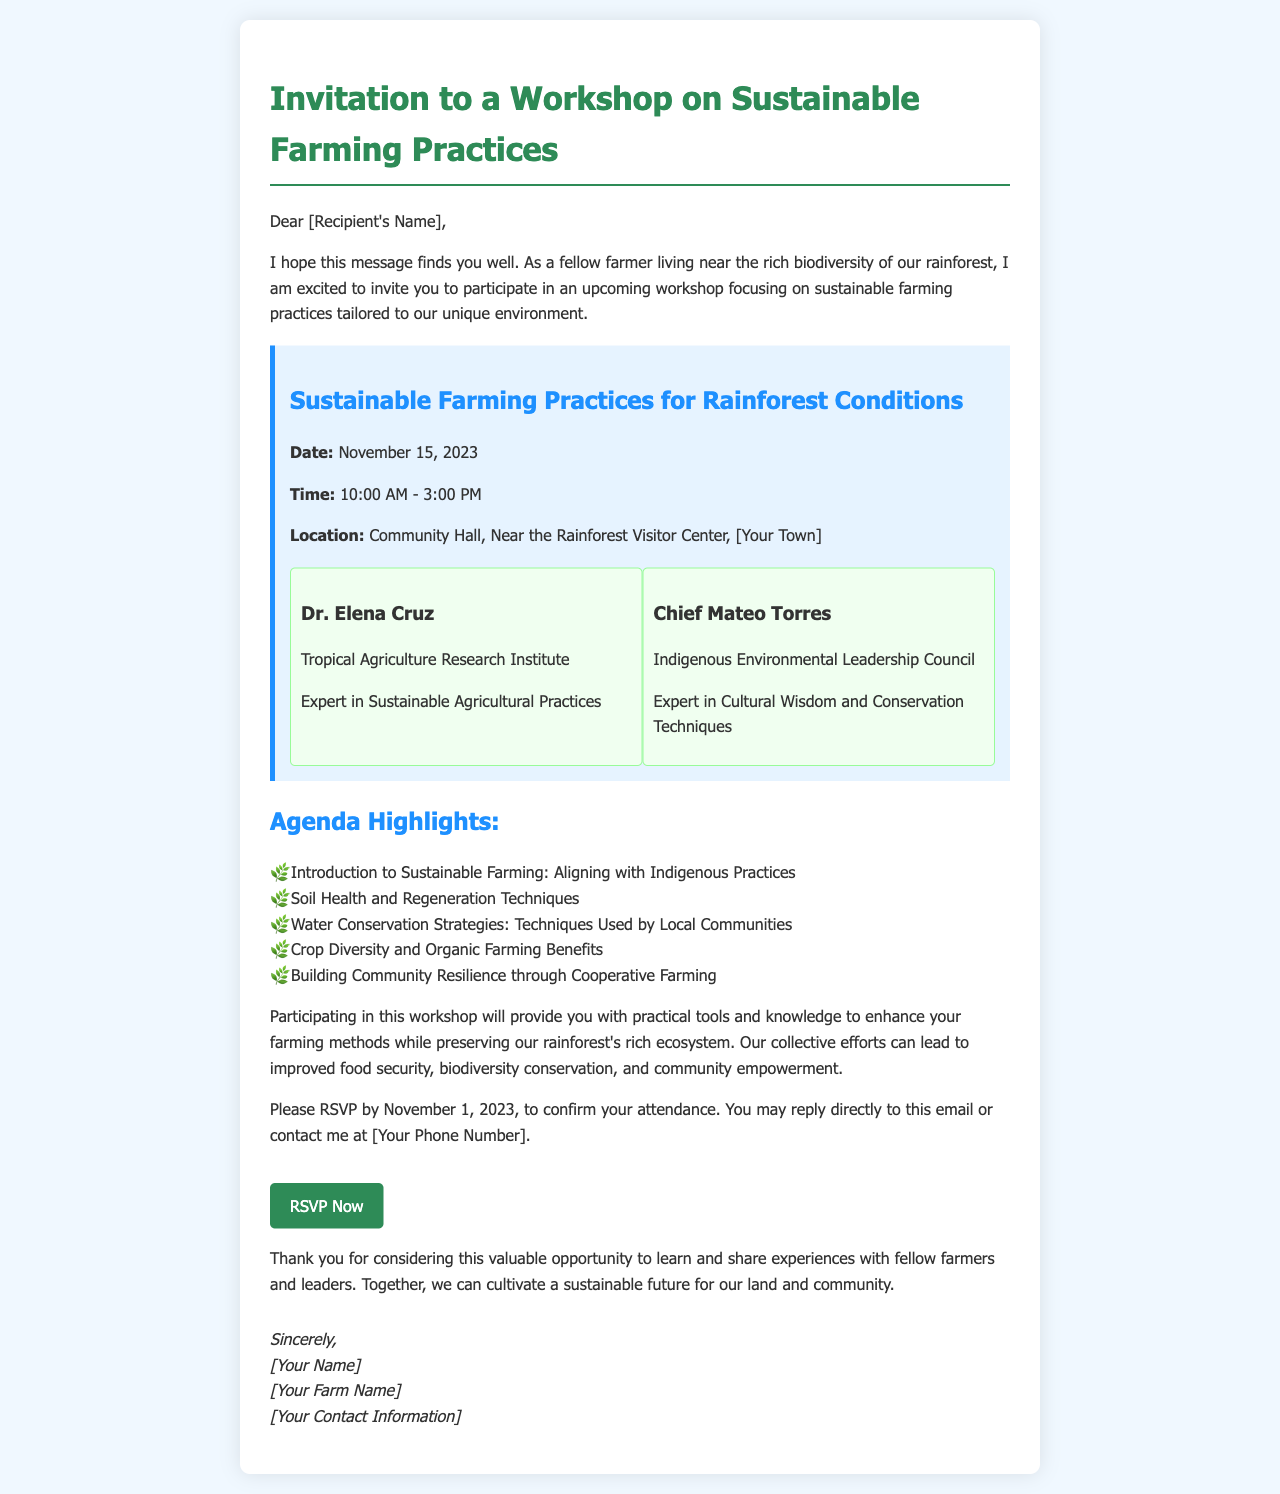What is the date of the workshop? The date of the workshop is clearly stated in the document as November 15, 2023.
Answer: November 15, 2023 Who is one of the facilitators? The document lists two facilitators, one of whom is Dr. Elena Cruz from the Tropical Agriculture Research Institute.
Answer: Dr. Elena Cruz What time does the workshop start? The workshop's starting time is mentioned in the document, which is 10:00 AM.
Answer: 10:00 AM What is one agenda highlight of the workshop? The document includes several agenda highlights, one of which is "Soil Health and Regeneration Techniques."
Answer: Soil Health and Regeneration Techniques What is the location of the workshop? The workshop's location is provided as "Community Hall, Near the Rainforest Visitor Center, [Your Town]."
Answer: Community Hall, Near the Rainforest Visitor Center, [Your Town] Why is participating in this workshop beneficial? The document explains that it offers practical tools and knowledge to enhance farming methods while preserving the rainforest ecosystem.
Answer: Enhance farming methods while preserving the rainforest ecosystem What is the RSVP deadline? The deadline to RSVP is mentioned in the document as November 1, 2023.
Answer: November 1, 2023 Who is the expert in Cultural Wisdom and Conservation Techniques? The document identifies Chief Mateo Torres as the expert in Cultural Wisdom and Conservation Techniques.
Answer: Chief Mateo Torres 